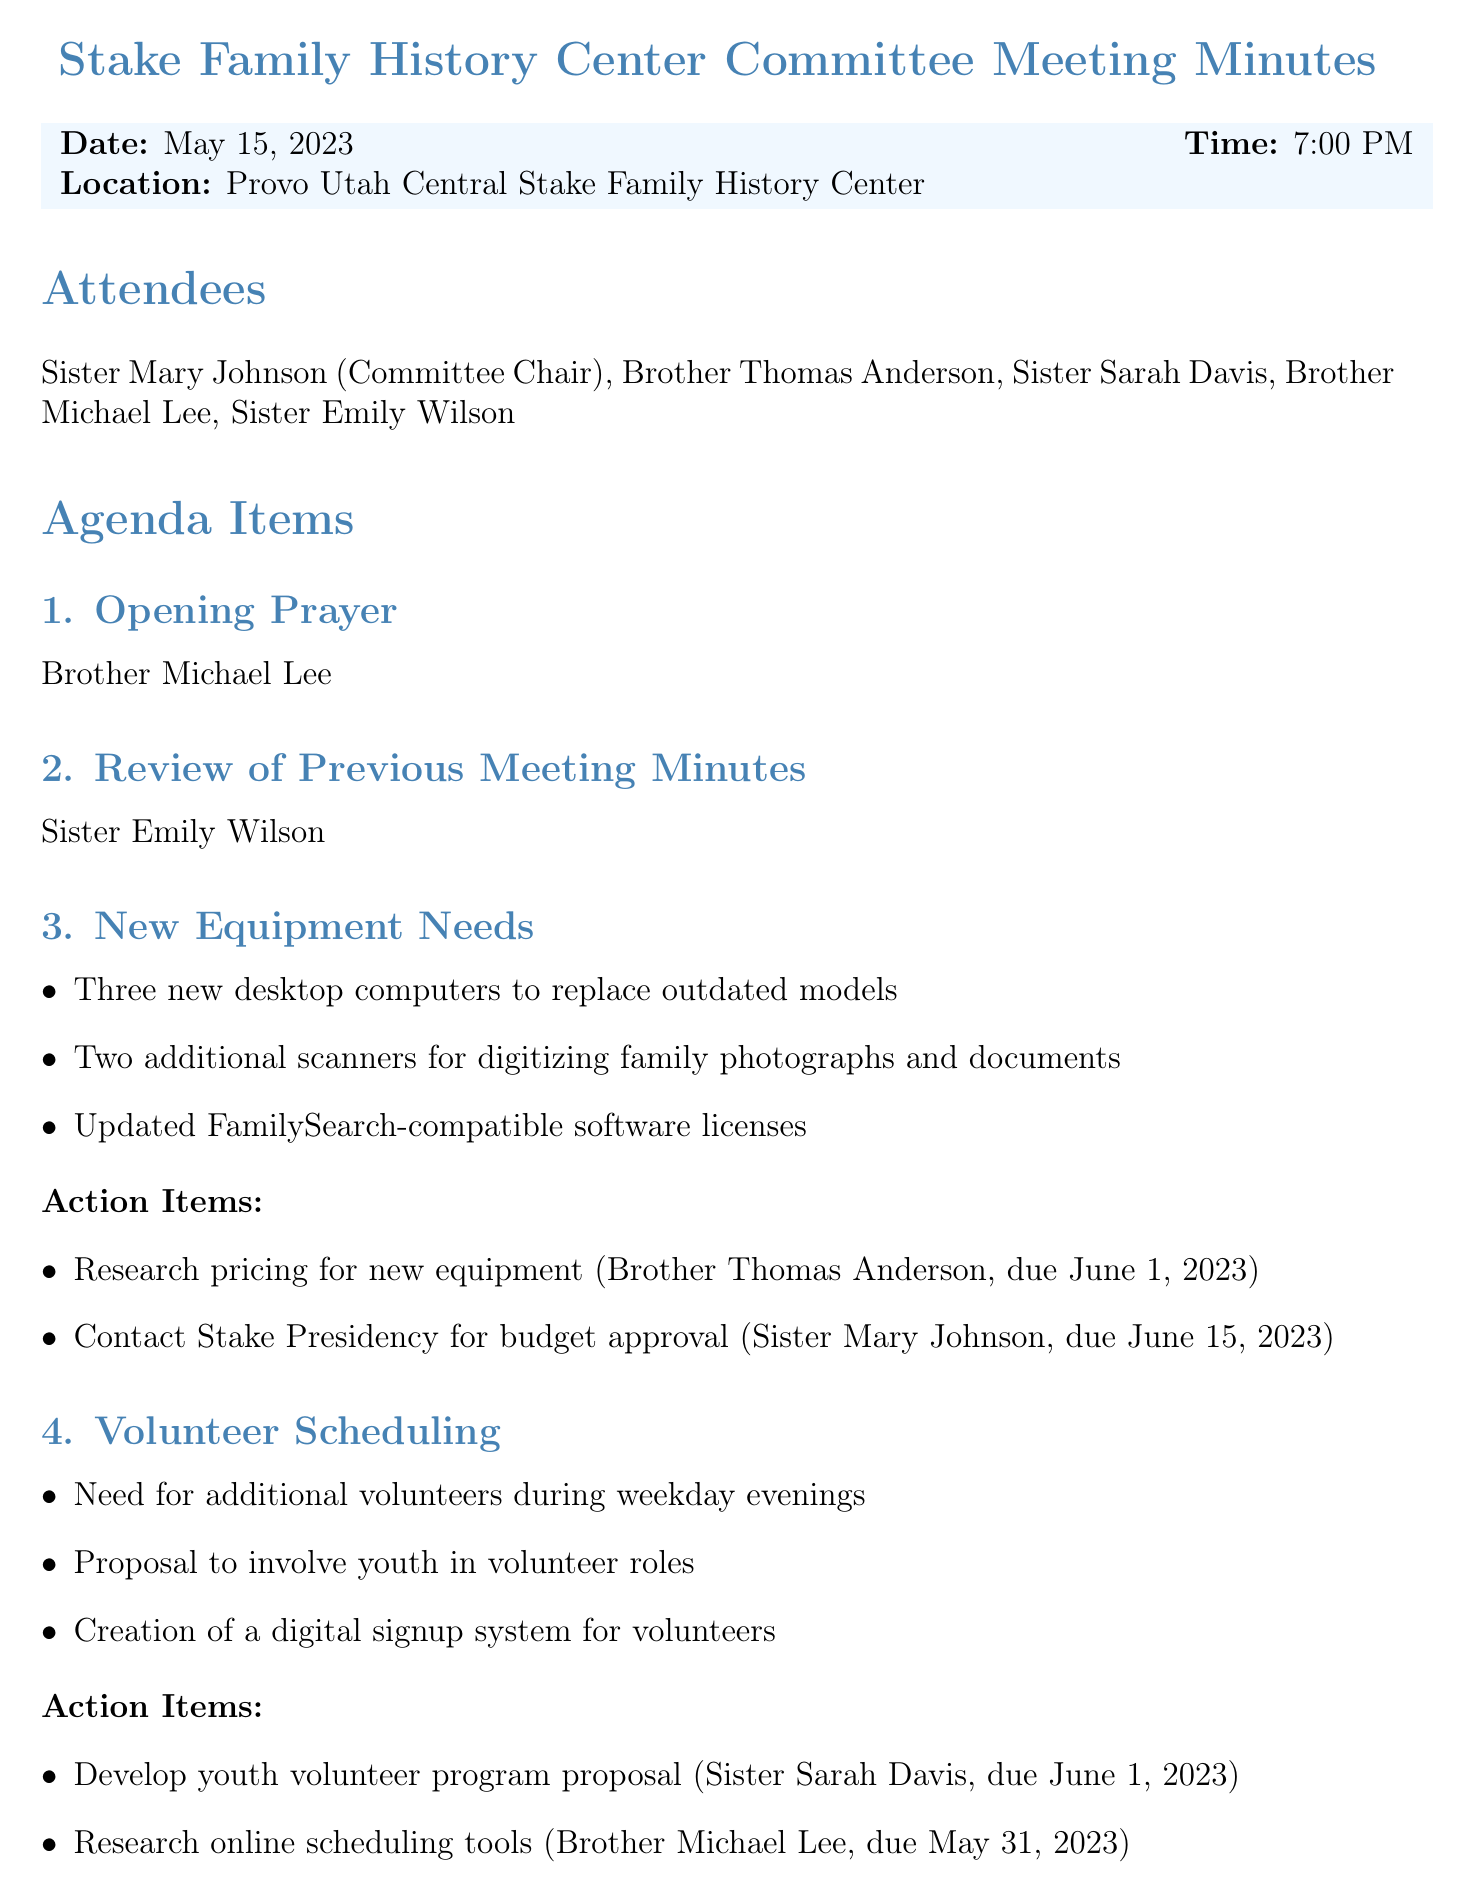what is the date of the meeting? The date of the meeting is explicitly mentioned in the document.
Answer: May 15, 2023 who is the Committee Chair? The document lists the attendees and specifies the Committee Chair.
Answer: Sister Mary Johnson how many new desktop computers are needed? The document states the specific number of new desktop computers required.
Answer: Three when is the next meeting scheduled? The next meeting date is provided in the document, specifying when it will occur.
Answer: June 19, 2023 who is responsible for researching pricing for new equipment? The document outlines action items along with the assigned individuals.
Answer: Brother Thomas Anderson what is the deadline for the youth volunteer program proposal? The document indicates the due date for several action items, including this one.
Answer: June 1, 2023 how many scanners are requested? The document includes information regarding the need for additional scanners.
Answer: Two what event is planned for July 8, 2023? The document lists upcoming family history events, specifying one set for that date.
Answer: Family History Fair which sister is creating a flyer for the Family History Fair? The action items in the document specify who is responsible for creating the flyer.
Answer: Sister Emily Wilson 